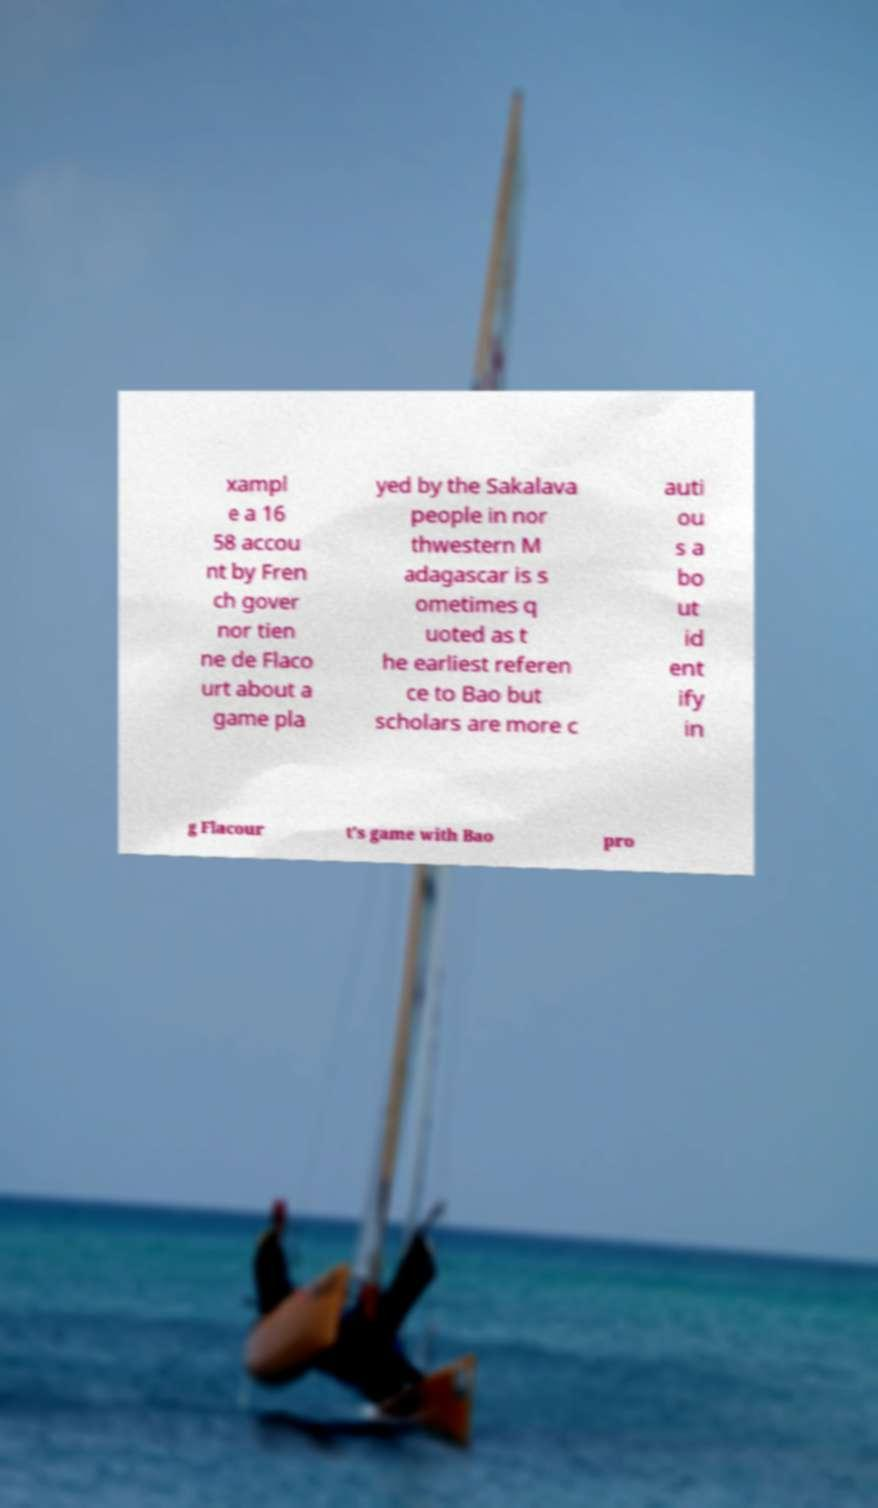Could you assist in decoding the text presented in this image and type it out clearly? xampl e a 16 58 accou nt by Fren ch gover nor tien ne de Flaco urt about a game pla yed by the Sakalava people in nor thwestern M adagascar is s ometimes q uoted as t he earliest referen ce to Bao but scholars are more c auti ou s a bo ut id ent ify in g Flacour t's game with Bao pro 